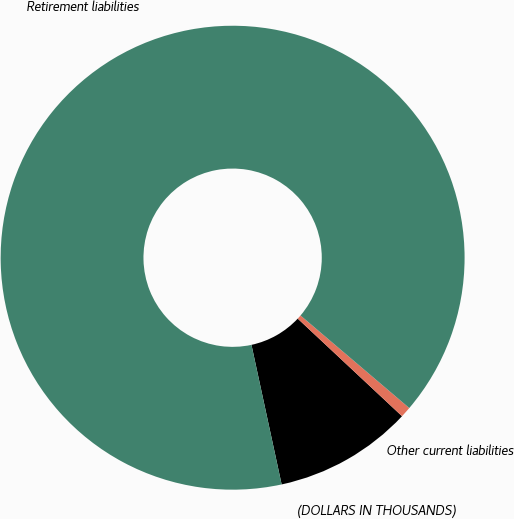Convert chart to OTSL. <chart><loc_0><loc_0><loc_500><loc_500><pie_chart><fcel>(DOLLARS IN THOUSANDS)<fcel>Other current liabilities<fcel>Retirement liabilities<nl><fcel>9.64%<fcel>0.75%<fcel>89.61%<nl></chart> 